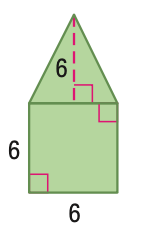Question: Find the area of the figure. Round to the nearest tenth if necessary.
Choices:
A. 36
B. 54
C. 72
D. 108
Answer with the letter. Answer: B Question: Find the perimeter of the figure. Round to the nearest tenth if necessary.
Choices:
A. 24.0
B. 24.7
C. 25.4
D. 31.4
Answer with the letter. Answer: D 